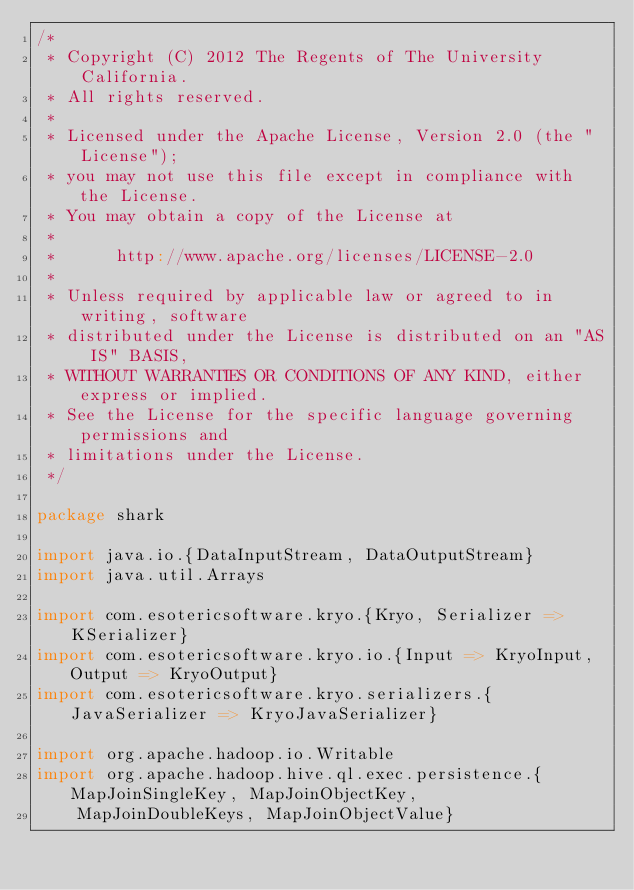<code> <loc_0><loc_0><loc_500><loc_500><_Scala_>/*
 * Copyright (C) 2012 The Regents of The University California.
 * All rights reserved.
 *
 * Licensed under the Apache License, Version 2.0 (the "License");
 * you may not use this file except in compliance with the License.
 * You may obtain a copy of the License at
 *
 *      http://www.apache.org/licenses/LICENSE-2.0
 *
 * Unless required by applicable law or agreed to in writing, software
 * distributed under the License is distributed on an "AS IS" BASIS,
 * WITHOUT WARRANTIES OR CONDITIONS OF ANY KIND, either express or implied.
 * See the License for the specific language governing permissions and
 * limitations under the License.
 */

package shark

import java.io.{DataInputStream, DataOutputStream}
import java.util.Arrays

import com.esotericsoftware.kryo.{Kryo, Serializer => KSerializer}
import com.esotericsoftware.kryo.io.{Input => KryoInput, Output => KryoOutput}
import com.esotericsoftware.kryo.serializers.{JavaSerializer => KryoJavaSerializer}

import org.apache.hadoop.io.Writable
import org.apache.hadoop.hive.ql.exec.persistence.{MapJoinSingleKey, MapJoinObjectKey,
    MapJoinDoubleKeys, MapJoinObjectValue}
</code> 